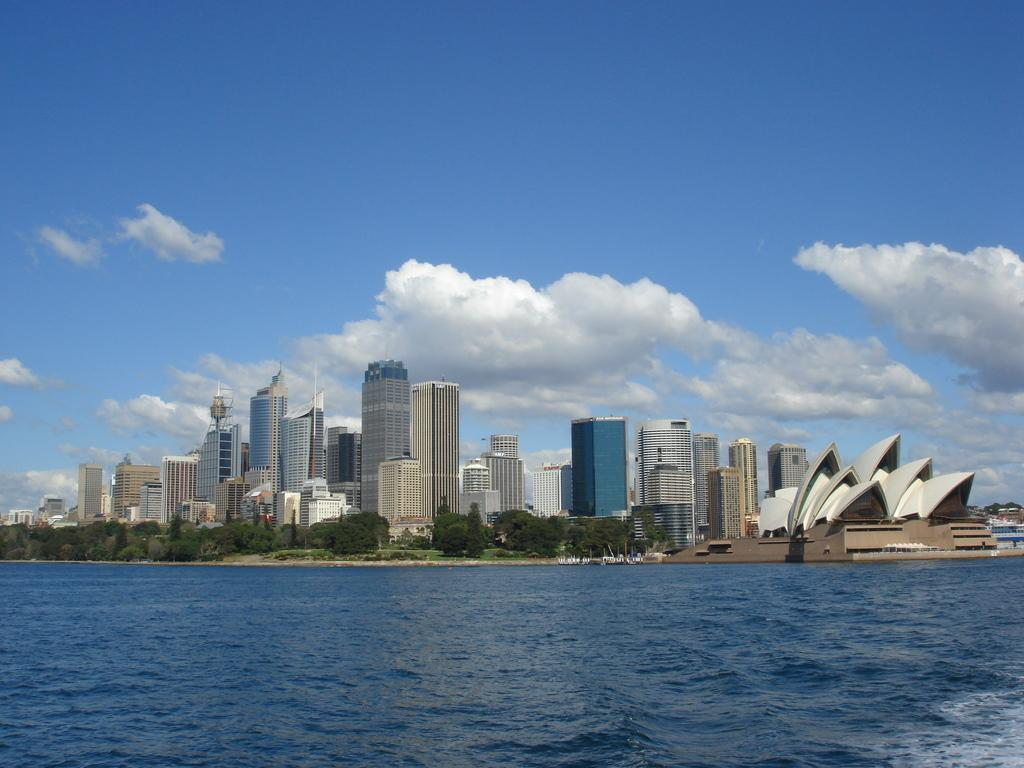What is the primary element visible in the image? There is water in the image. What can be seen in the distance behind the water? There are trees, buildings, clouds, and the sky visible in the background of the image. Can you describe the natural elements in the background? There are trees and clouds in the background of the image. What type of structures can be seen in the background? There are buildings visible in the background of the image. How many sheep are present in the image? There are no sheep visible in the image. What type of fabric is used to make the linen in the image? There is no linen present in the image. 